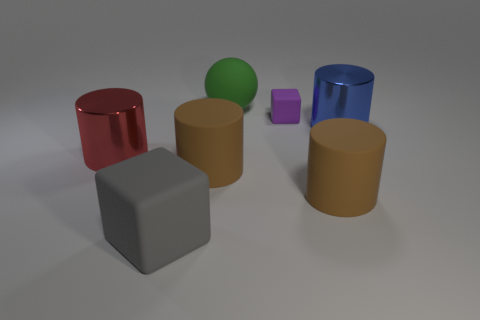Subtract all red metallic cylinders. How many cylinders are left? 3 Add 1 tiny green things. How many objects exist? 8 Subtract all spheres. How many objects are left? 6 Subtract 3 cylinders. How many cylinders are left? 1 Subtract all purple blocks. How many blocks are left? 1 Subtract all gray blocks. How many brown cylinders are left? 2 Subtract all yellow balls. Subtract all yellow cylinders. How many balls are left? 1 Subtract all gray objects. Subtract all gray rubber blocks. How many objects are left? 5 Add 2 big metal things. How many big metal things are left? 4 Add 6 big cyan matte cylinders. How many big cyan matte cylinders exist? 6 